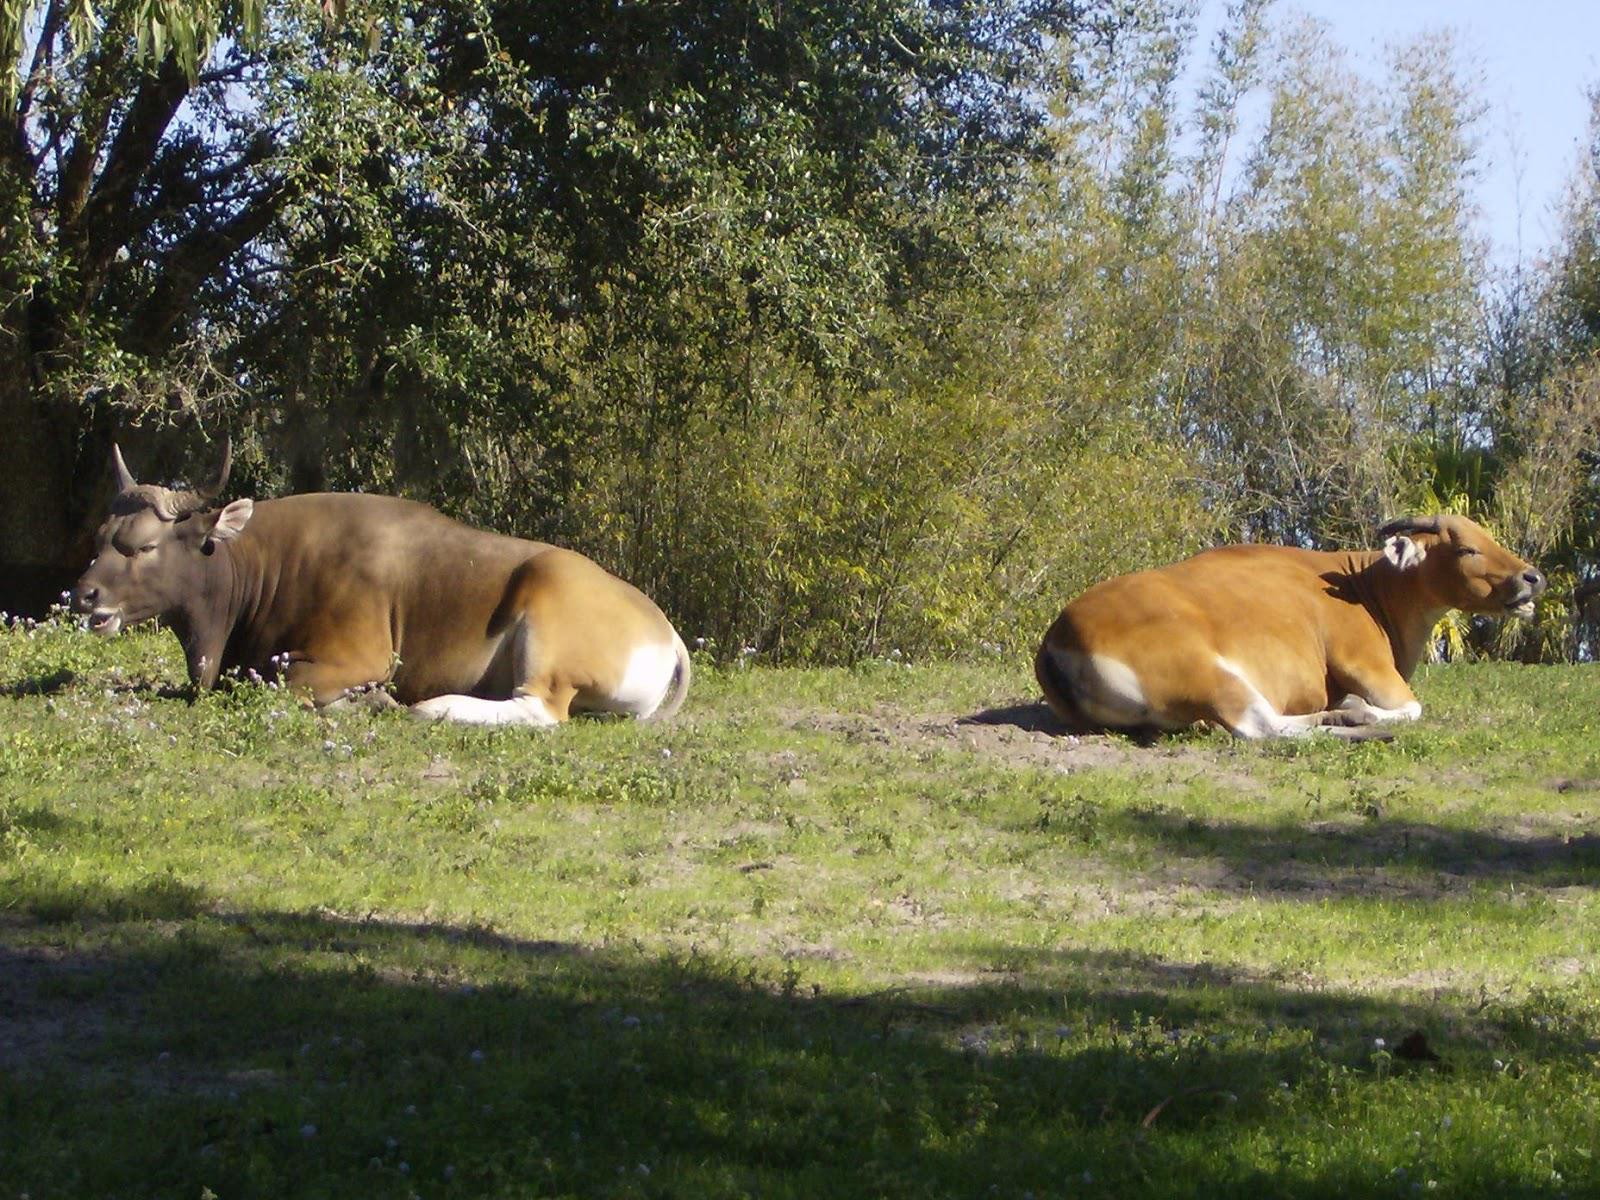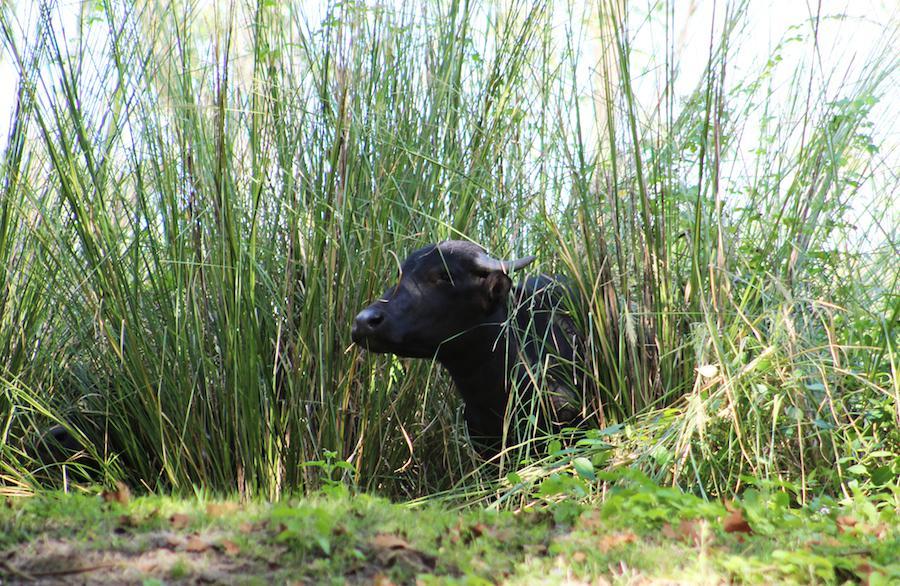The first image is the image on the left, the second image is the image on the right. Evaluate the accuracy of this statement regarding the images: "There are exactly two animals in the image on the left.". Is it true? Answer yes or no. Yes. 